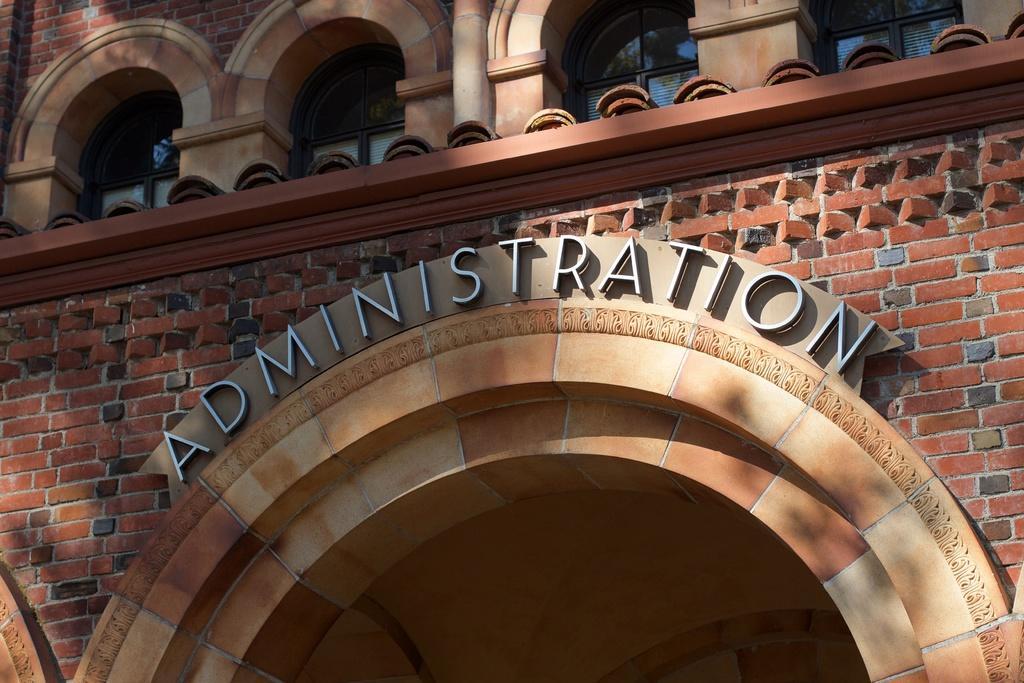Can you describe this image briefly? In this image I can see there is a building with text written on it. 